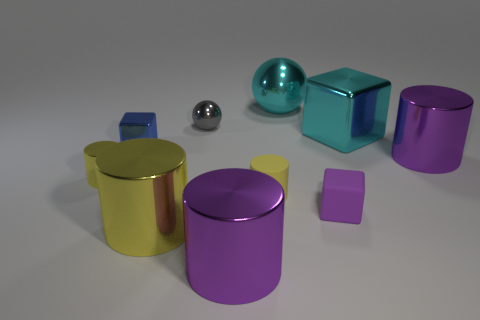How many yellow cylinders must be subtracted to get 1 yellow cylinders? 2 Subtract all cyan balls. How many yellow cylinders are left? 3 Subtract all large yellow cylinders. How many cylinders are left? 4 Subtract 2 cylinders. How many cylinders are left? 3 Subtract all red cylinders. Subtract all brown blocks. How many cylinders are left? 5 Subtract all cubes. How many objects are left? 7 Subtract 0 green blocks. How many objects are left? 10 Subtract all tiny yellow matte cylinders. Subtract all purple cubes. How many objects are left? 8 Add 5 big cyan objects. How many big cyan objects are left? 7 Add 5 large yellow cylinders. How many large yellow cylinders exist? 6 